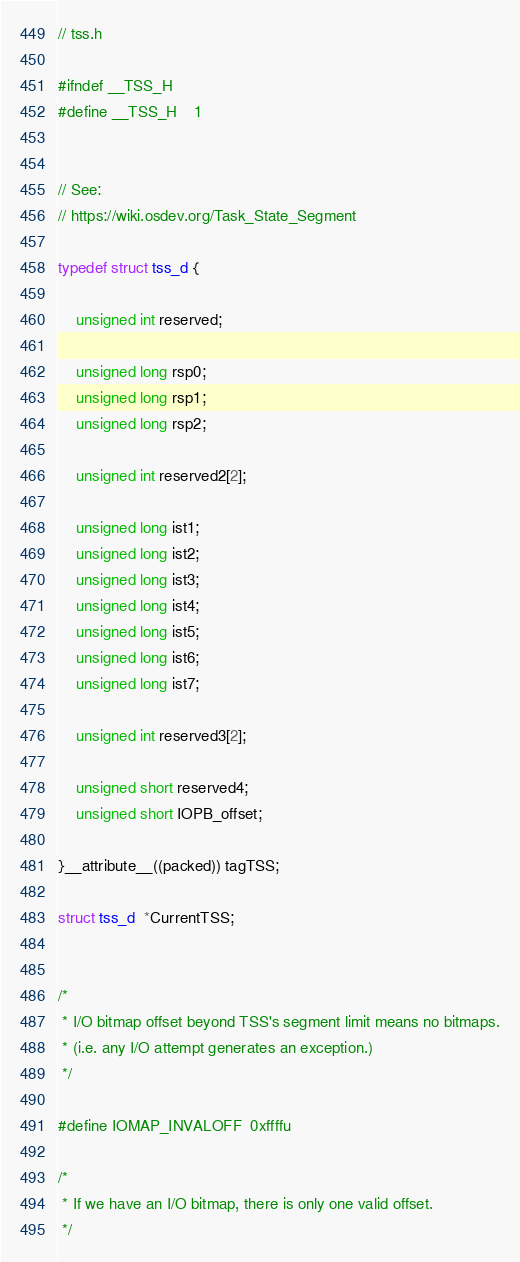<code> <loc_0><loc_0><loc_500><loc_500><_C_>
// tss.h

#ifndef __TSS_H
#define __TSS_H    1


// See:
// https://wiki.osdev.org/Task_State_Segment

typedef struct tss_d {

    unsigned int reserved;
    
    unsigned long rsp0; 
    unsigned long rsp1; 
    unsigned long rsp2;

    unsigned int reserved2[2];

    unsigned long ist1; 
    unsigned long ist2; 
    unsigned long ist3; 
    unsigned long ist4; 
    unsigned long ist5; 
    unsigned long ist6; 
    unsigned long ist7;

    unsigned int reserved3[2];

    unsigned short reserved4;
    unsigned short IOPB_offset;

}__attribute__((packed)) tagTSS;

struct tss_d  *CurrentTSS;


/*
 * I/O bitmap offset beyond TSS's segment limit means no bitmaps.
 * (i.e. any I/O attempt generates an exception.)
 */

#define IOMAP_INVALOFF  0xffffu

/*
 * If we have an I/O bitmap, there is only one valid offset.
 */</code> 